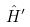Convert formula to latex. <formula><loc_0><loc_0><loc_500><loc_500>\hat { H } ^ { \prime }</formula> 